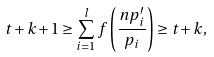Convert formula to latex. <formula><loc_0><loc_0><loc_500><loc_500>t + k + 1 \geq \sum _ { i = 1 } ^ { l } f \left ( \frac { n p _ { i } ^ { \prime } } { p _ { i } } \right ) \geq t + k ,</formula> 